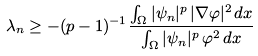<formula> <loc_0><loc_0><loc_500><loc_500>\lambda _ { n } \geq - ( p - 1 ) ^ { - 1 } \frac { \int _ { \Omega } | \psi _ { n } | ^ { p } \, | \nabla \varphi | ^ { 2 } \, d x } { \int _ { \Omega } | \psi _ { n } | ^ { p } \, \varphi ^ { 2 } \, d x }</formula> 